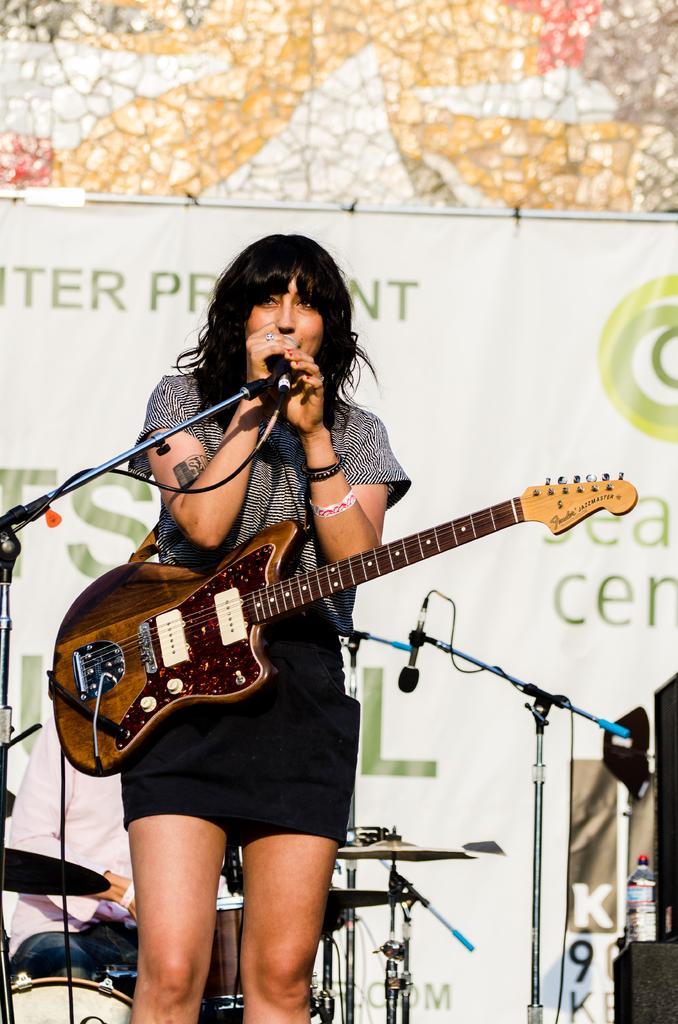In one or two sentences, can you explain what this image depicts? Here we can see a woman with a guitar on her and singing a song with a microphone in her hand and behind her we can see drums and a banner present 